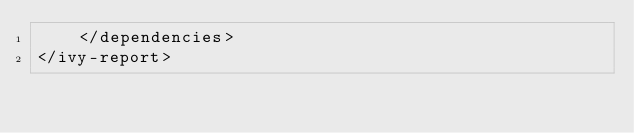<code> <loc_0><loc_0><loc_500><loc_500><_XML_>	</dependencies>
</ivy-report>
</code> 